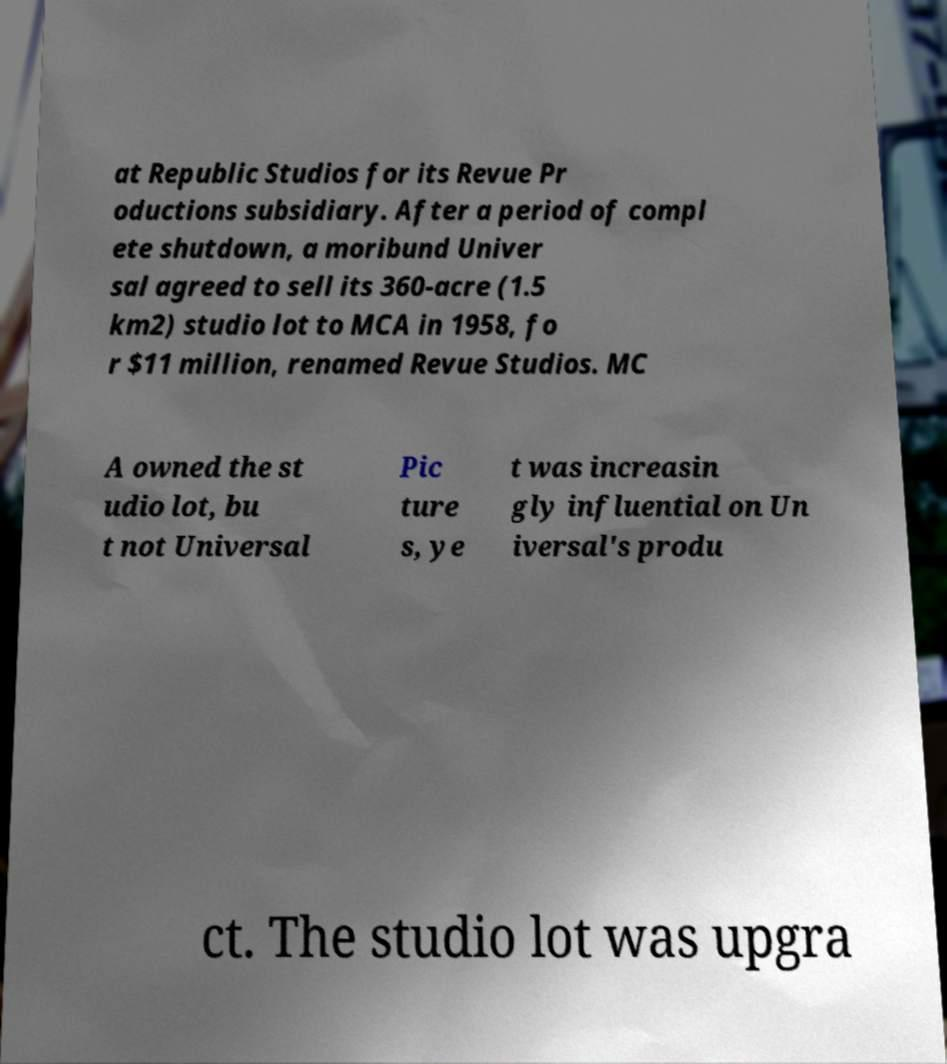For documentation purposes, I need the text within this image transcribed. Could you provide that? at Republic Studios for its Revue Pr oductions subsidiary. After a period of compl ete shutdown, a moribund Univer sal agreed to sell its 360-acre (1.5 km2) studio lot to MCA in 1958, fo r $11 million, renamed Revue Studios. MC A owned the st udio lot, bu t not Universal Pic ture s, ye t was increasin gly influential on Un iversal's produ ct. The studio lot was upgra 